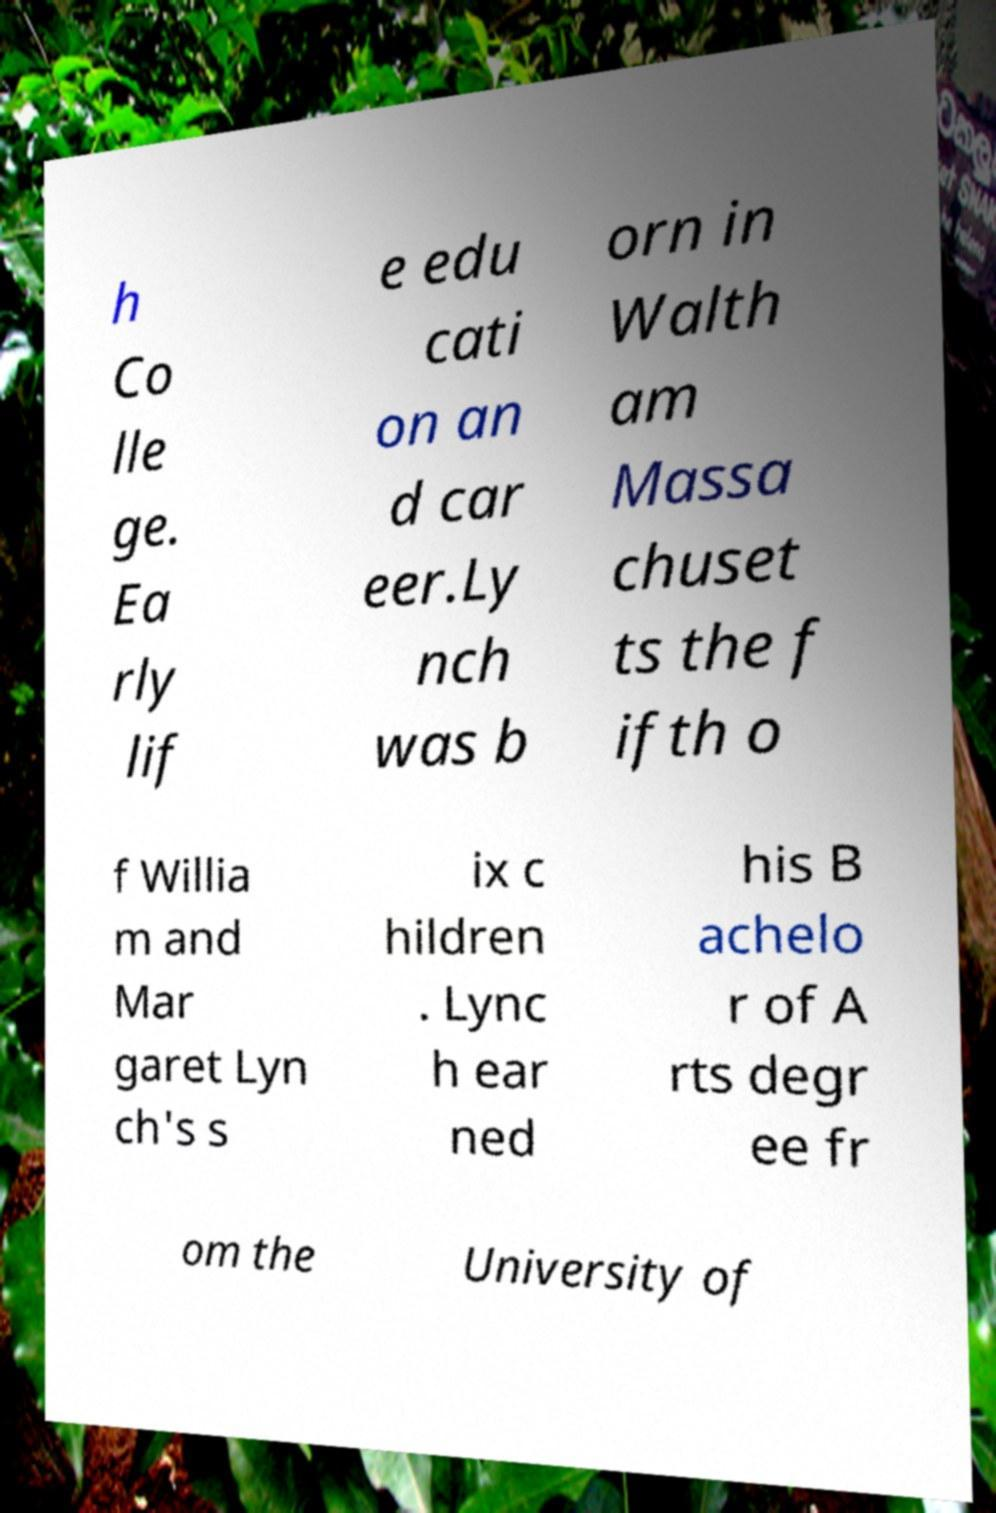For documentation purposes, I need the text within this image transcribed. Could you provide that? h Co lle ge. Ea rly lif e edu cati on an d car eer.Ly nch was b orn in Walth am Massa chuset ts the f ifth o f Willia m and Mar garet Lyn ch's s ix c hildren . Lync h ear ned his B achelo r of A rts degr ee fr om the University of 